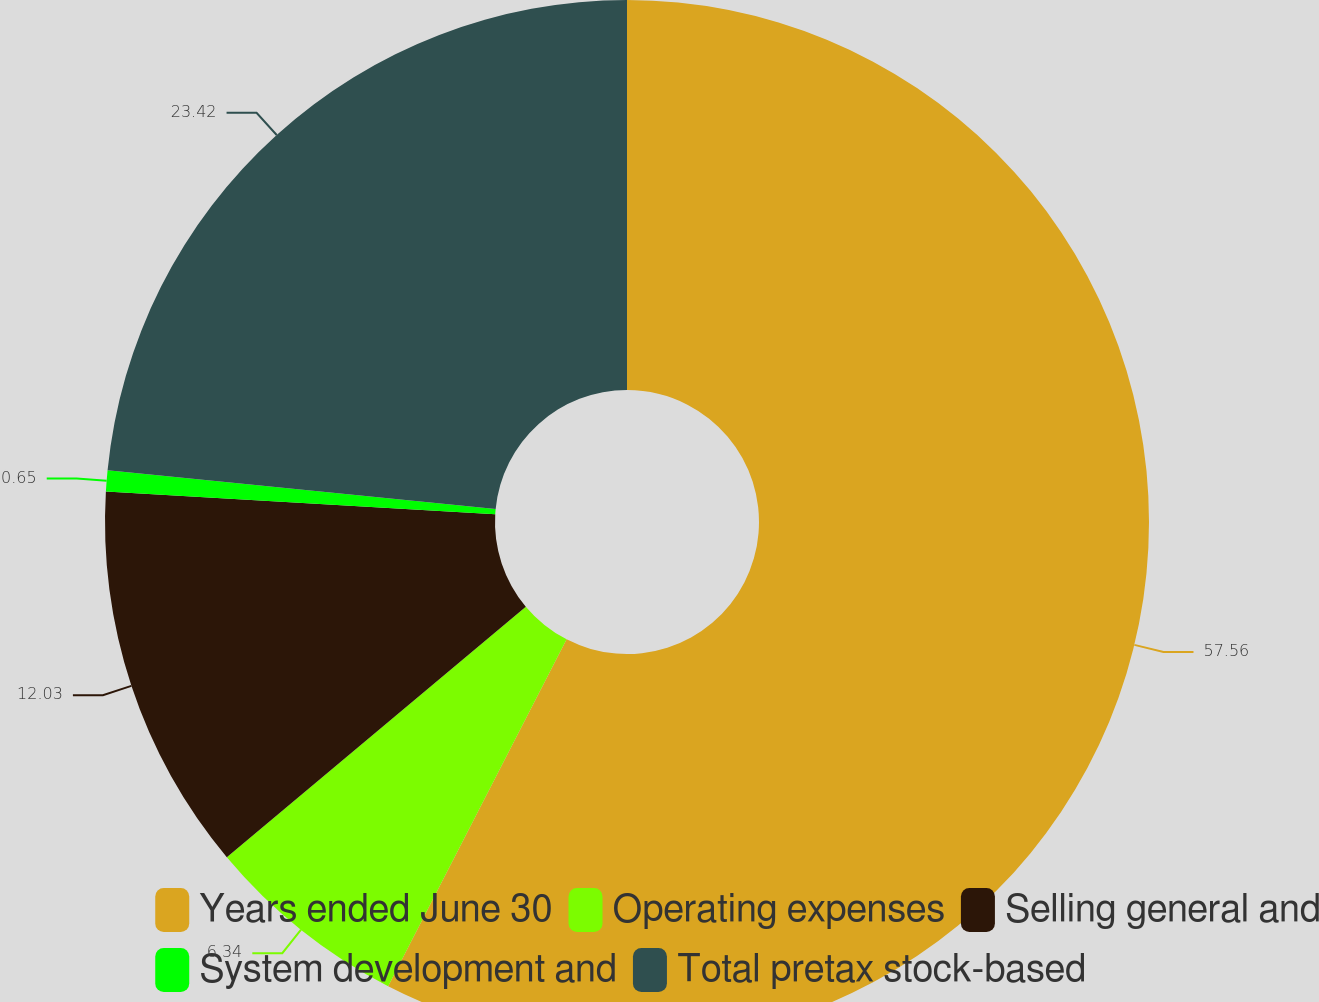Convert chart to OTSL. <chart><loc_0><loc_0><loc_500><loc_500><pie_chart><fcel>Years ended June 30<fcel>Operating expenses<fcel>Selling general and<fcel>System development and<fcel>Total pretax stock-based<nl><fcel>57.57%<fcel>6.34%<fcel>12.03%<fcel>0.65%<fcel>23.42%<nl></chart> 